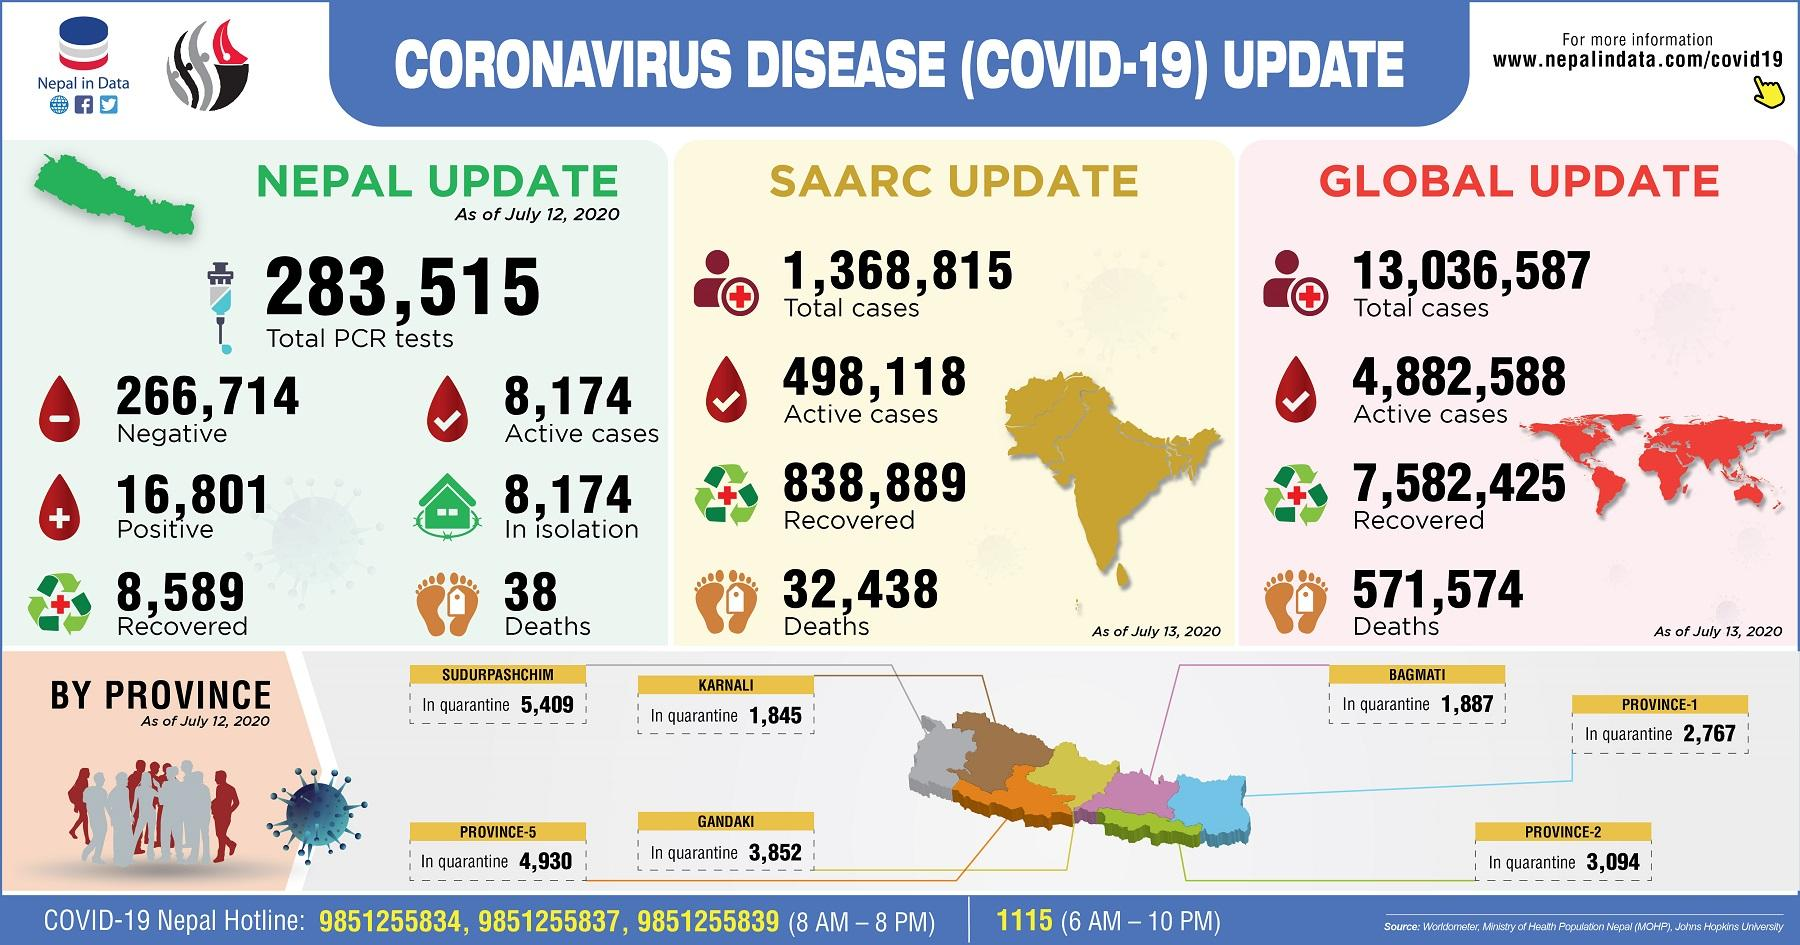Indicate a few pertinent items in this graphic. As of July 12, 2020, a total of 1,887 individuals were in quarantine in the Bagmati province of Nepal. On July 13, 2020, it was reported that globally there had been 571,574 COVID-19 deaths. As of July 12, 2020, a total of 1,845 individuals were quarantined in the Karnali province of Nepal. As of July 13, 2020, a total of 32,438 COVID-19 deaths had been reported in the SAARC region. As of July 12, 2020, a total of 16,801 positive COVID-19 cases had been reported in Nepal. 